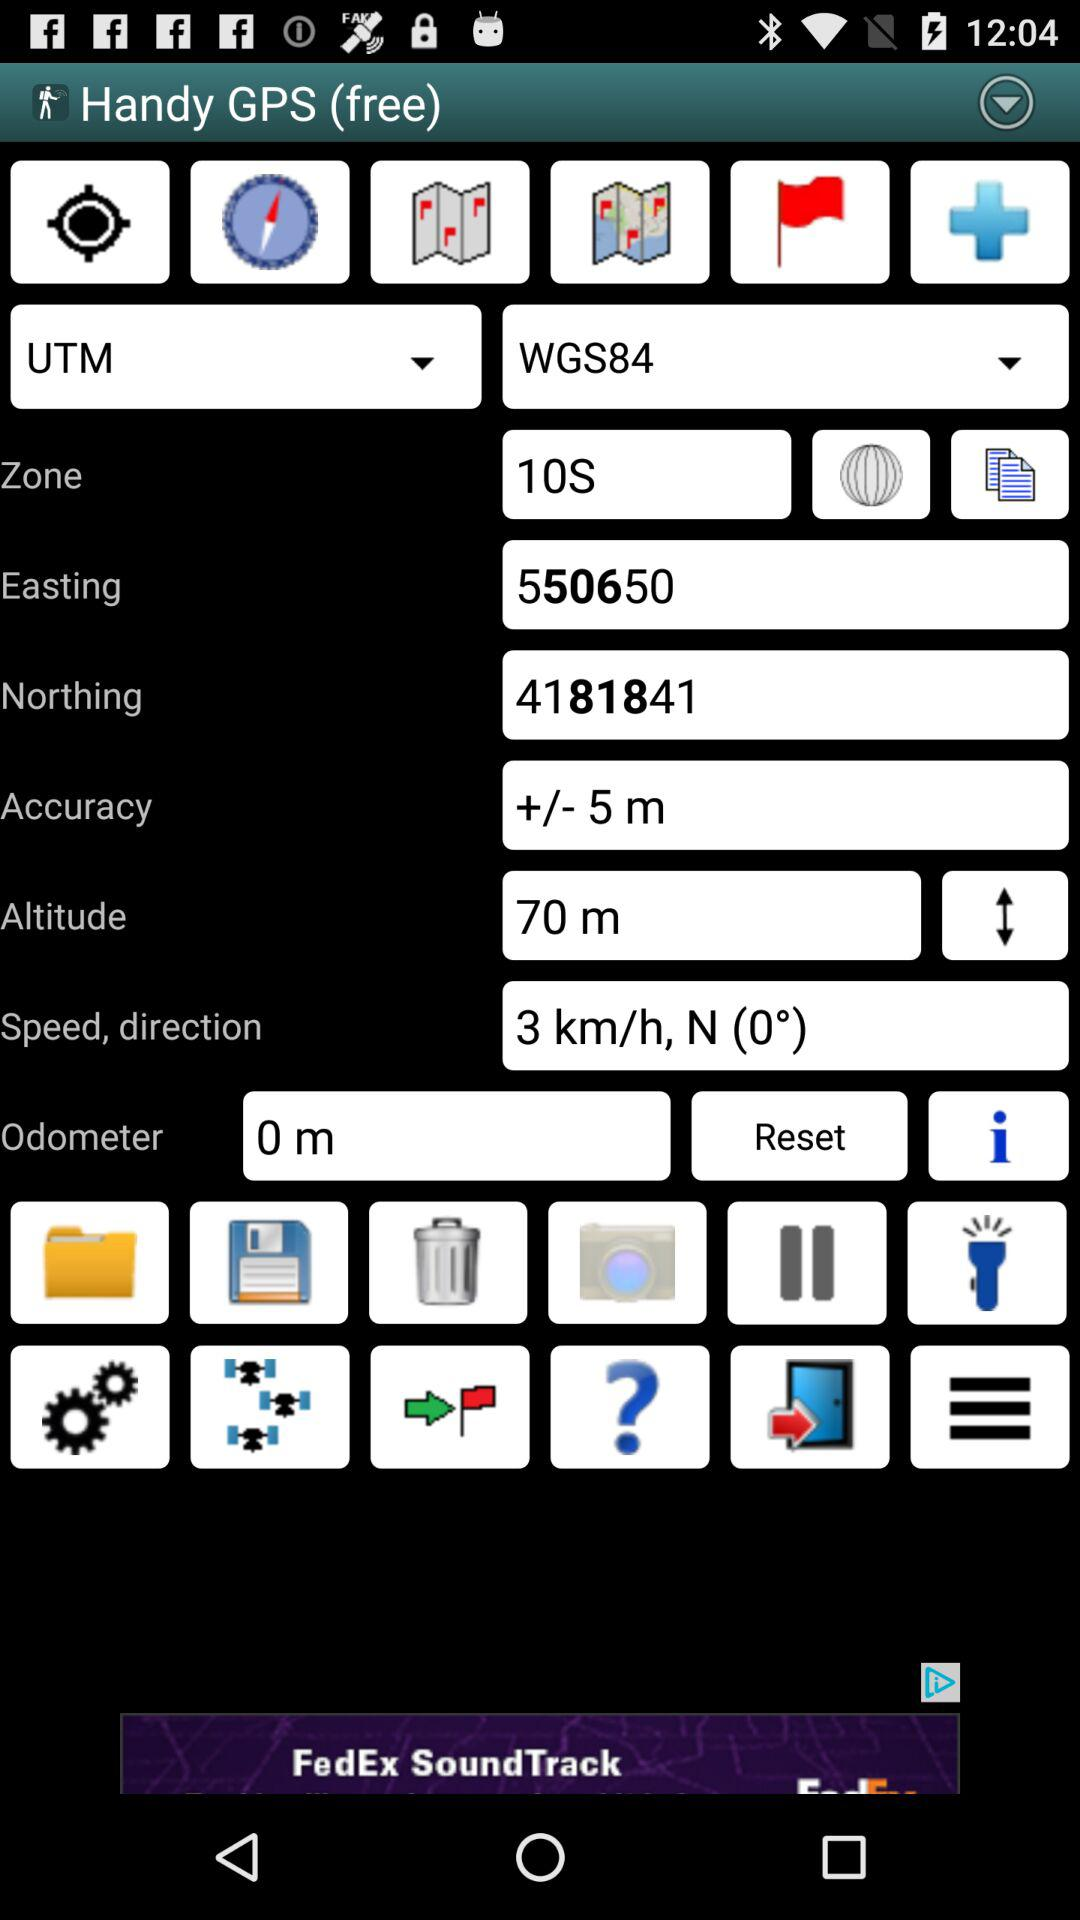How many meters is the odometer reading?
Answer the question using a single word or phrase. 0 m 